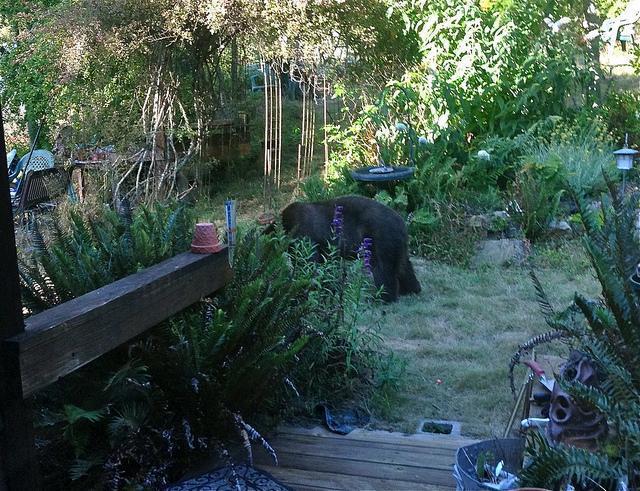How many potted plants are there?
Give a very brief answer. 3. 